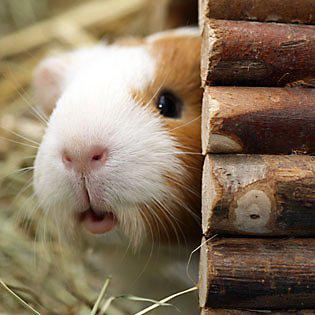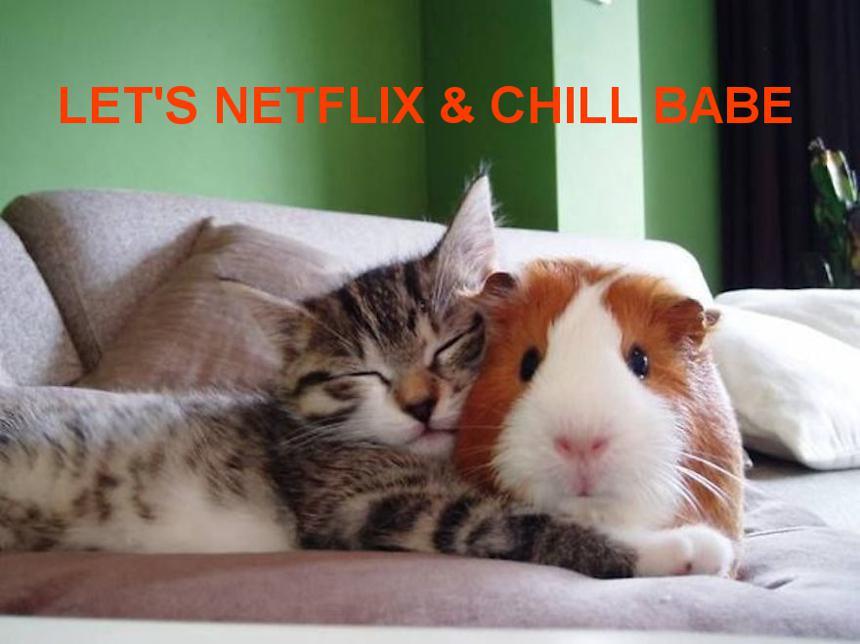The first image is the image on the left, the second image is the image on the right. For the images shown, is this caption "There is at least one guinea pig with food in its mouth" true? Answer yes or no. No. The first image is the image on the left, the second image is the image on the right. Analyze the images presented: Is the assertion "guinea pigs have food in their mouths" valid? Answer yes or no. No. 